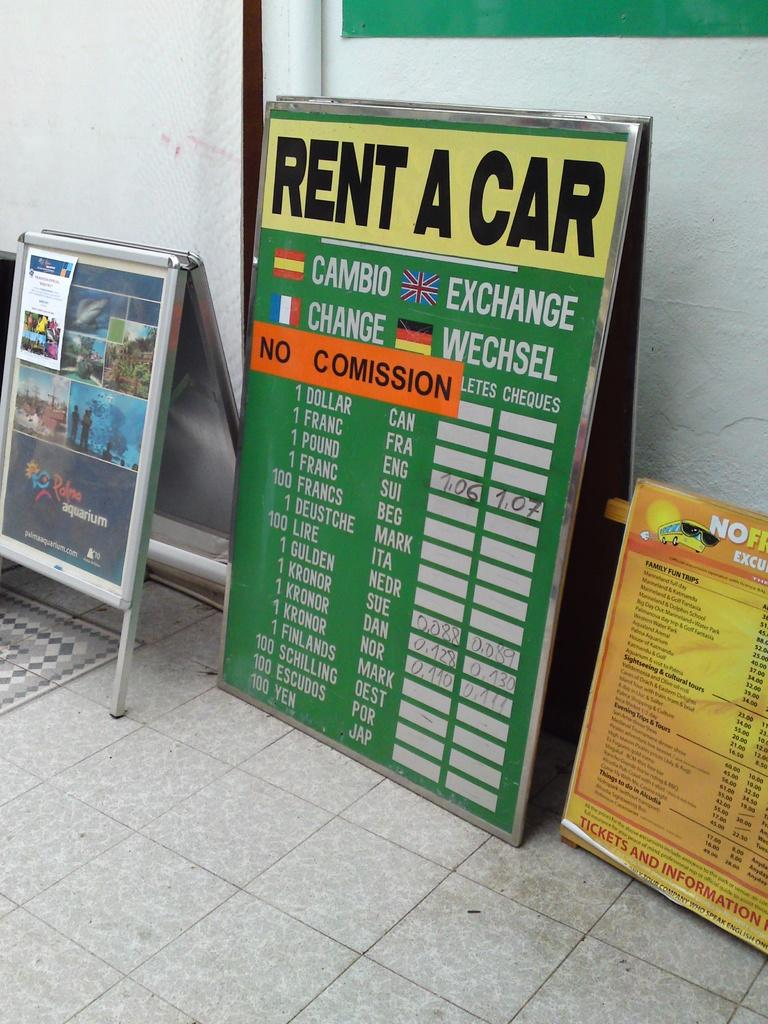<image>
Describe the image concisely. A large predominantly green flip board sign which reads Rent A Car. 